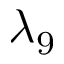<formula> <loc_0><loc_0><loc_500><loc_500>\lambda _ { 9 }</formula> 